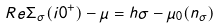<formula> <loc_0><loc_0><loc_500><loc_500>R e \Sigma _ { \sigma } ( i 0 ^ { + } ) - \mu = h \sigma - \mu _ { 0 } ( n _ { \sigma } )</formula> 